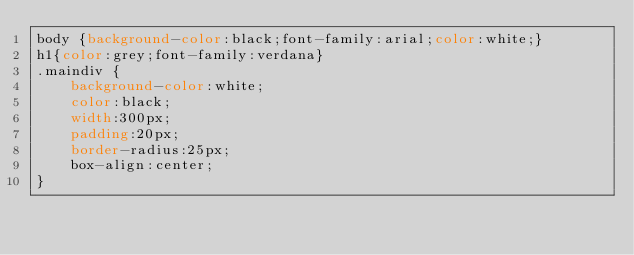Convert code to text. <code><loc_0><loc_0><loc_500><loc_500><_CSS_>body {background-color:black;font-family:arial;color:white;}
h1{color:grey;font-family:verdana}
.maindiv {
    background-color:white;
    color:black;
    width:300px;
    padding:20px;
    border-radius:25px;
    box-align:center;
}
</code> 